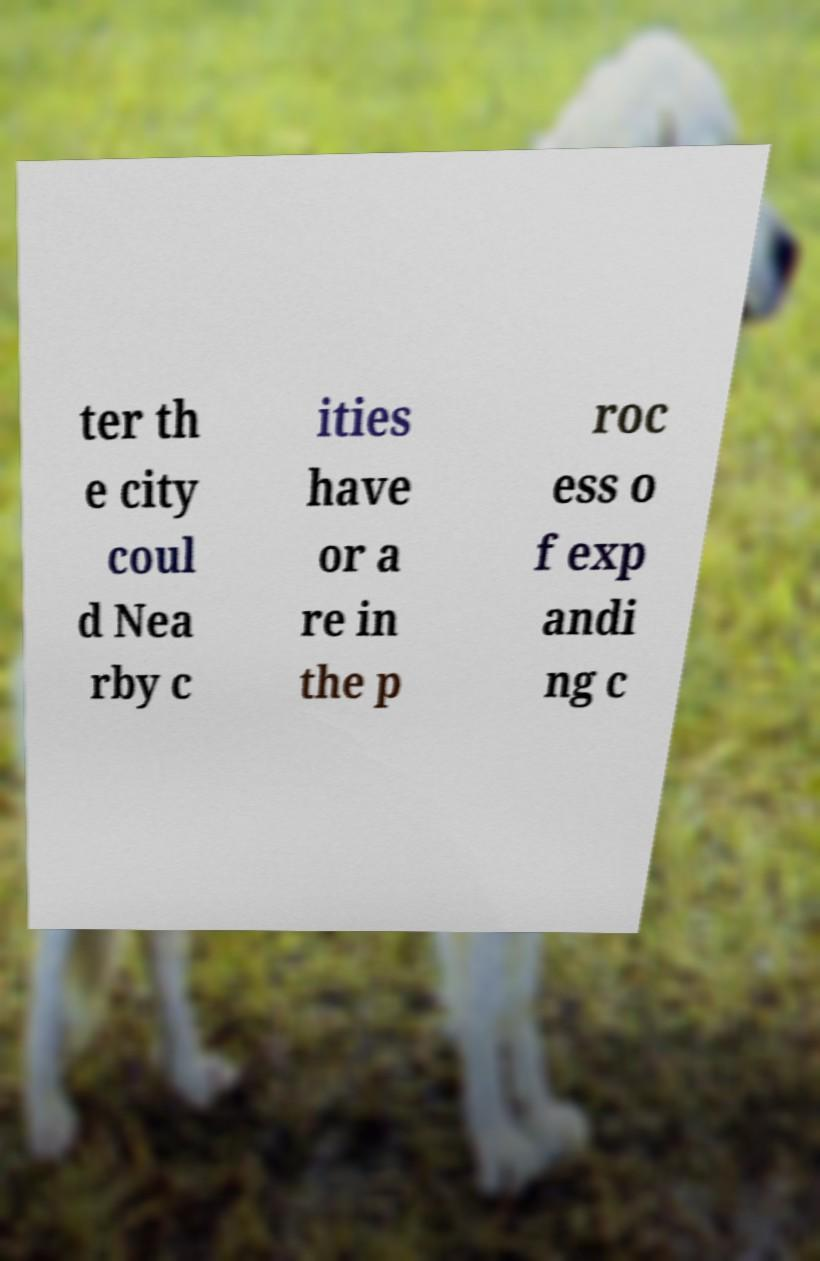For documentation purposes, I need the text within this image transcribed. Could you provide that? ter th e city coul d Nea rby c ities have or a re in the p roc ess o f exp andi ng c 